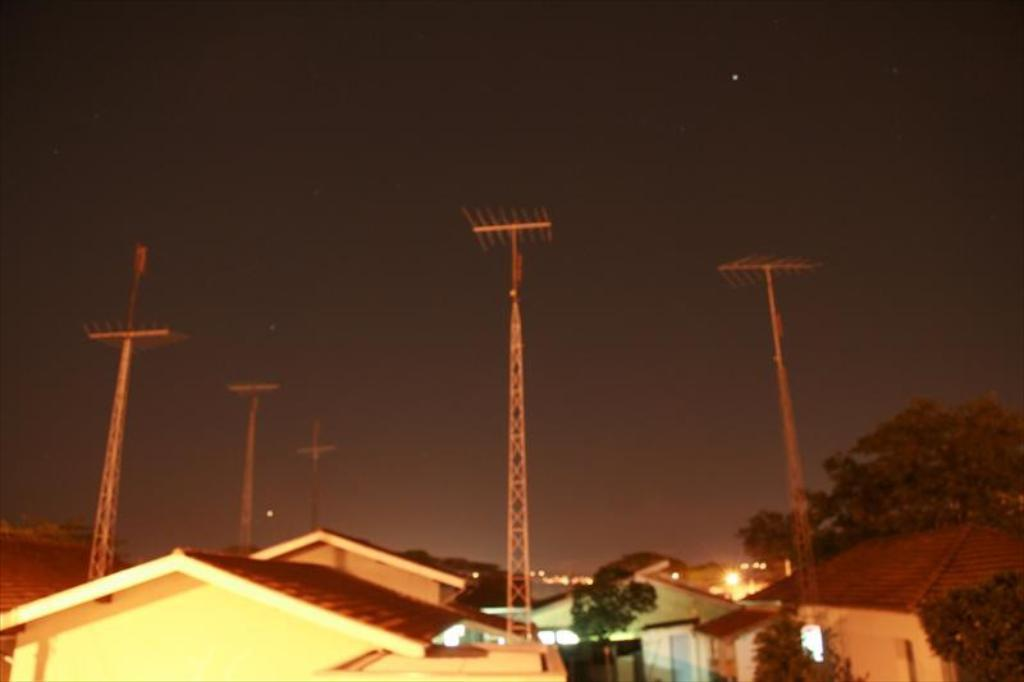What type of structures can be seen in the image? There are many buildings in the image. What other natural elements are present in the image? There are trees in the image. Are there any man-made objects visible on top of the buildings? Yes, there are antennas in the image. Can you describe the lighting conditions in the image? There is light visible in the image. What part of the natural environment is visible in the image? The sky is visible in the image. What celestial bodies can be seen in the sky? Stars are visible in the sky. What color is the girl holding a crayon in the image? There is no girl holding a crayon present in the image. What type of railway can be seen in the image? There is no railway present in the image. 